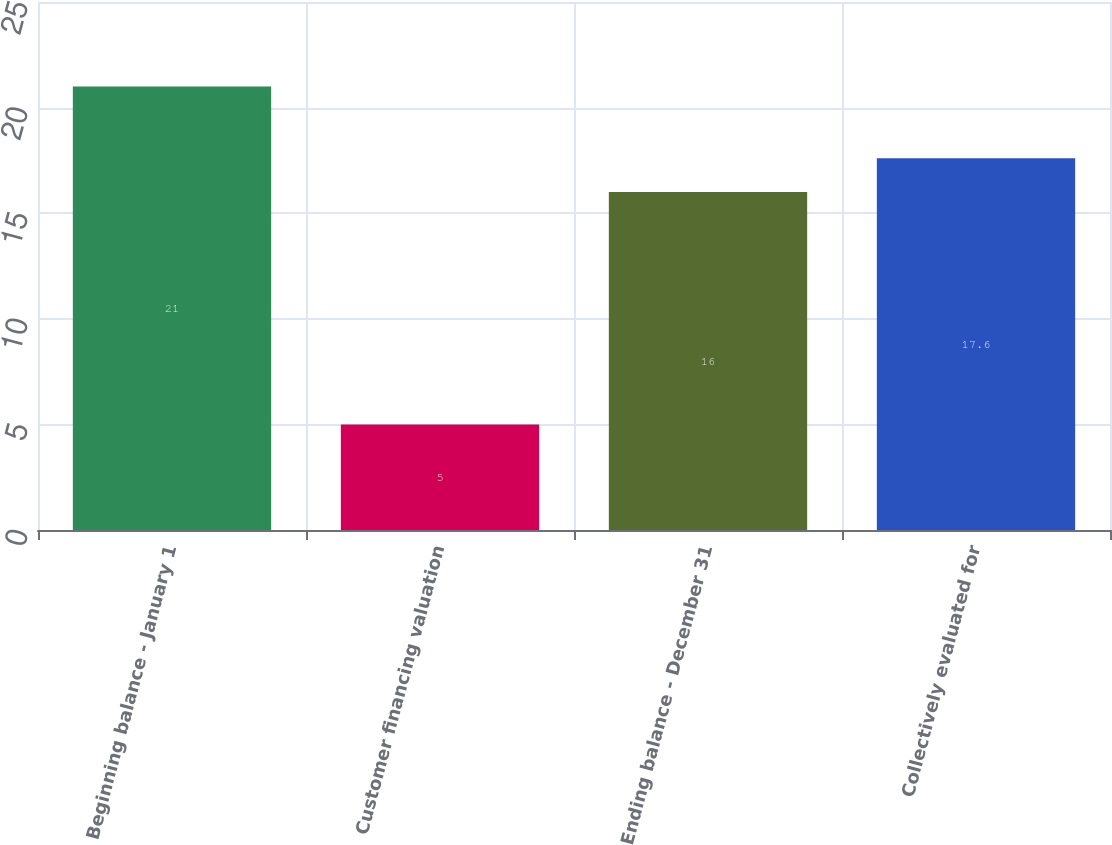Convert chart. <chart><loc_0><loc_0><loc_500><loc_500><bar_chart><fcel>Beginning balance - January 1<fcel>Customer financing valuation<fcel>Ending balance - December 31<fcel>Collectively evaluated for<nl><fcel>21<fcel>5<fcel>16<fcel>17.6<nl></chart> 